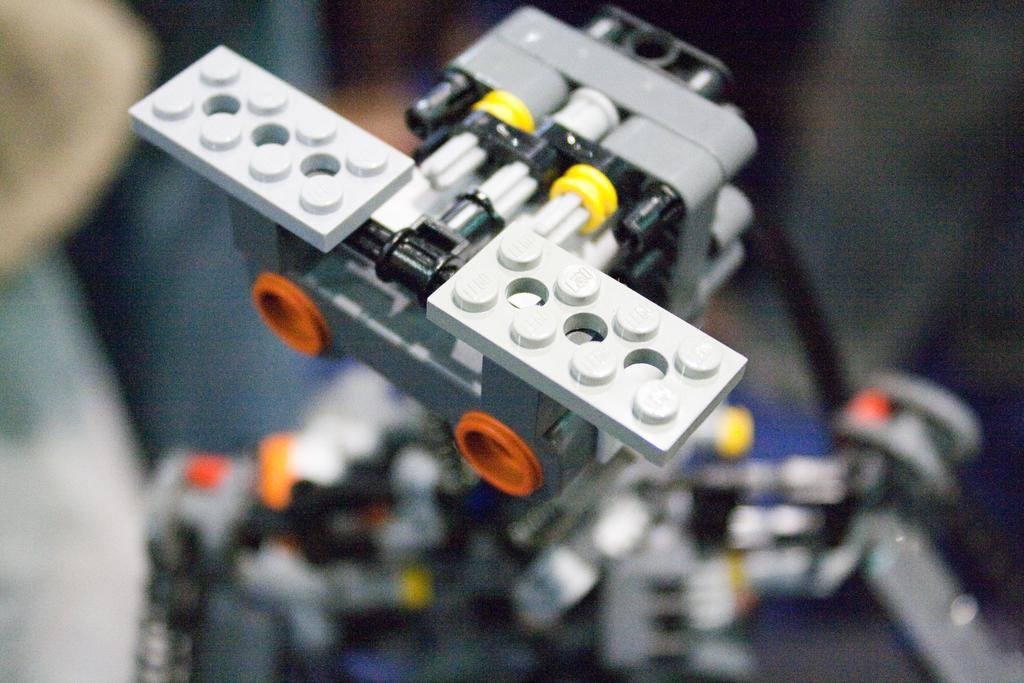What type of toy is in the image? There is a Lego toy in the image. What colors can be seen on the Lego toy? The Lego toy has white, grey, yellow, black, and orange colors. Can you describe the background of the image? The background of the image is blurred. What type of note is the Lego toy holding in the image? There is no note present in the image; it only features a Lego toy with various colors. 